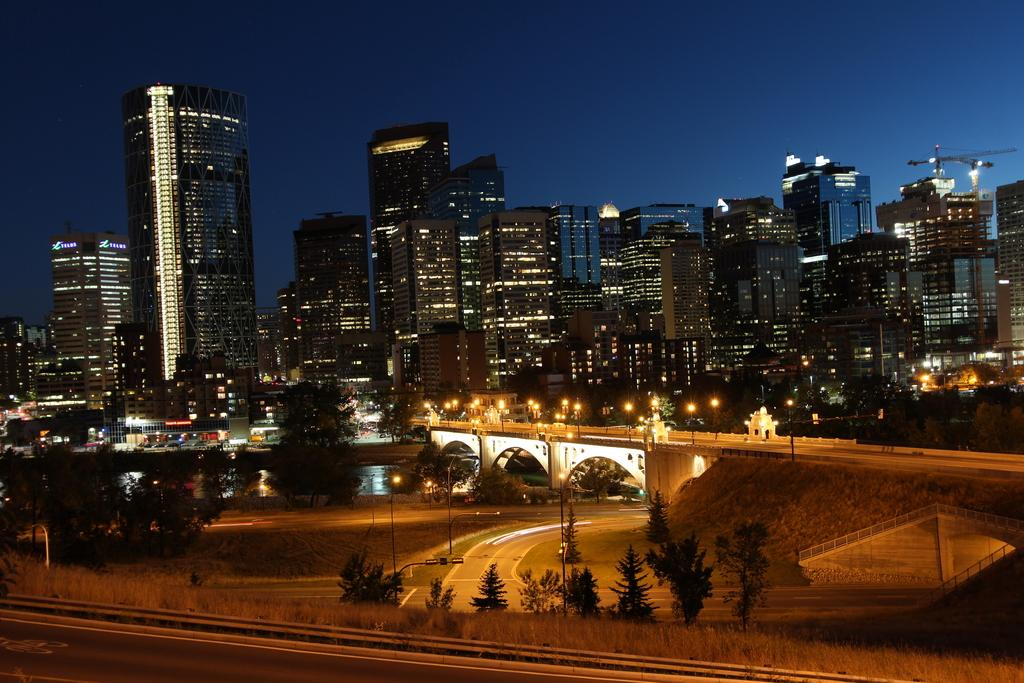What type of vegetation is at the bottom of the image? There are trees at the bottom of the image. What structure can be seen in the middle of the image? There is a bridge in the middle of the image. What type of structures have lights in the image? There are buildings with lights in the image. What is visible at the top of the image? The sky is visible at the top of the image. Can you tell me how many lamps are hanging from the bridge in the image? There is no information about lamps hanging from the bridge in the image. What type of pest can be seen crawling on the trees at the bottom of the image? There are no pests visible on the trees in the image. 